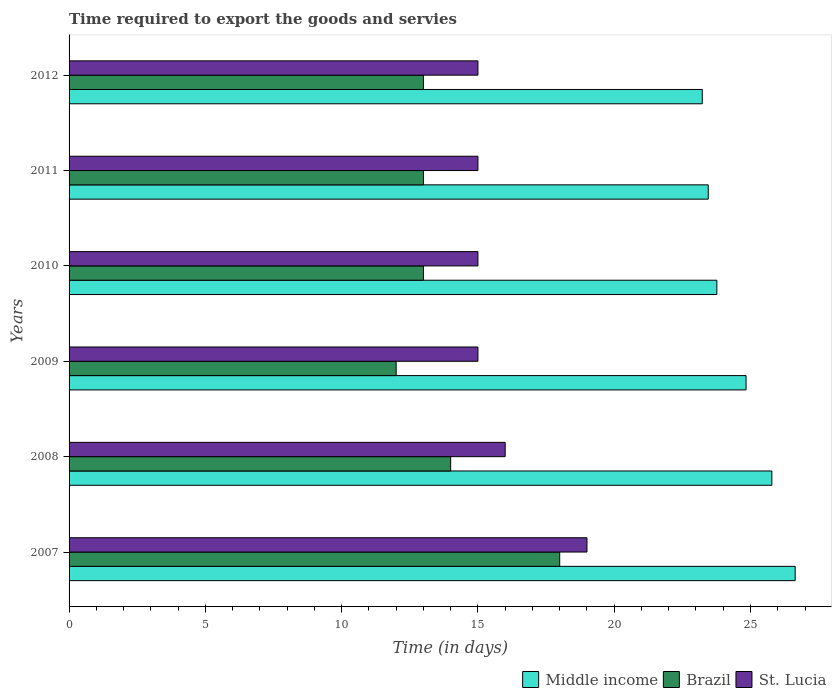How many different coloured bars are there?
Provide a succinct answer. 3. How many groups of bars are there?
Ensure brevity in your answer.  6. Are the number of bars per tick equal to the number of legend labels?
Offer a terse response. Yes. Are the number of bars on each tick of the Y-axis equal?
Provide a succinct answer. Yes. How many bars are there on the 4th tick from the top?
Your answer should be compact. 3. How many bars are there on the 3rd tick from the bottom?
Ensure brevity in your answer.  3. What is the number of days required to export the goods and services in St. Lucia in 2011?
Keep it short and to the point. 15. Across all years, what is the maximum number of days required to export the goods and services in Middle income?
Provide a short and direct response. 26.64. What is the difference between the number of days required to export the goods and services in St. Lucia in 2010 and that in 2011?
Give a very brief answer. 0. What is the difference between the number of days required to export the goods and services in Middle income in 2011 and the number of days required to export the goods and services in Brazil in 2007?
Make the answer very short. 5.45. What is the average number of days required to export the goods and services in Middle income per year?
Make the answer very short. 24.62. In the year 2007, what is the difference between the number of days required to export the goods and services in Brazil and number of days required to export the goods and services in St. Lucia?
Your response must be concise. -1. In how many years, is the number of days required to export the goods and services in St. Lucia greater than 26 days?
Your answer should be compact. 0. What is the ratio of the number of days required to export the goods and services in Brazil in 2008 to that in 2010?
Keep it short and to the point. 1.08. Is the difference between the number of days required to export the goods and services in Brazil in 2007 and 2009 greater than the difference between the number of days required to export the goods and services in St. Lucia in 2007 and 2009?
Provide a short and direct response. Yes. What is the difference between the highest and the lowest number of days required to export the goods and services in Middle income?
Provide a short and direct response. 3.41. Is the sum of the number of days required to export the goods and services in Middle income in 2009 and 2011 greater than the maximum number of days required to export the goods and services in Brazil across all years?
Your answer should be very brief. Yes. What does the 3rd bar from the bottom in 2010 represents?
Keep it short and to the point. St. Lucia. Is it the case that in every year, the sum of the number of days required to export the goods and services in St. Lucia and number of days required to export the goods and services in Middle income is greater than the number of days required to export the goods and services in Brazil?
Provide a short and direct response. Yes. How many bars are there?
Provide a short and direct response. 18. Are all the bars in the graph horizontal?
Provide a short and direct response. Yes. How many years are there in the graph?
Provide a succinct answer. 6. Are the values on the major ticks of X-axis written in scientific E-notation?
Ensure brevity in your answer.  No. How are the legend labels stacked?
Your answer should be very brief. Horizontal. What is the title of the graph?
Your response must be concise. Time required to export the goods and servies. Does "Malaysia" appear as one of the legend labels in the graph?
Your answer should be very brief. No. What is the label or title of the X-axis?
Offer a terse response. Time (in days). What is the Time (in days) of Middle income in 2007?
Give a very brief answer. 26.64. What is the Time (in days) of Middle income in 2008?
Offer a terse response. 25.78. What is the Time (in days) in Brazil in 2008?
Offer a very short reply. 14. What is the Time (in days) of Middle income in 2009?
Give a very brief answer. 24.84. What is the Time (in days) in Brazil in 2009?
Your response must be concise. 12. What is the Time (in days) of Middle income in 2010?
Provide a short and direct response. 23.77. What is the Time (in days) in Brazil in 2010?
Give a very brief answer. 13. What is the Time (in days) in St. Lucia in 2010?
Keep it short and to the point. 15. What is the Time (in days) in Middle income in 2011?
Offer a terse response. 23.45. What is the Time (in days) of Middle income in 2012?
Give a very brief answer. 23.23. Across all years, what is the maximum Time (in days) in Middle income?
Your answer should be very brief. 26.64. Across all years, what is the maximum Time (in days) in Brazil?
Give a very brief answer. 18. Across all years, what is the maximum Time (in days) of St. Lucia?
Your answer should be very brief. 19. Across all years, what is the minimum Time (in days) in Middle income?
Offer a terse response. 23.23. Across all years, what is the minimum Time (in days) of Brazil?
Keep it short and to the point. 12. What is the total Time (in days) in Middle income in the graph?
Ensure brevity in your answer.  147.7. What is the total Time (in days) in St. Lucia in the graph?
Your answer should be compact. 95. What is the difference between the Time (in days) of Middle income in 2007 and that in 2008?
Provide a short and direct response. 0.86. What is the difference between the Time (in days) in Brazil in 2007 and that in 2008?
Give a very brief answer. 4. What is the difference between the Time (in days) in St. Lucia in 2007 and that in 2008?
Provide a short and direct response. 3. What is the difference between the Time (in days) of Middle income in 2007 and that in 2009?
Provide a short and direct response. 1.8. What is the difference between the Time (in days) in Brazil in 2007 and that in 2009?
Your response must be concise. 6. What is the difference between the Time (in days) in Middle income in 2007 and that in 2010?
Your answer should be very brief. 2.87. What is the difference between the Time (in days) of Middle income in 2007 and that in 2011?
Offer a very short reply. 3.19. What is the difference between the Time (in days) in St. Lucia in 2007 and that in 2011?
Provide a short and direct response. 4. What is the difference between the Time (in days) in Middle income in 2007 and that in 2012?
Your answer should be very brief. 3.41. What is the difference between the Time (in days) in St. Lucia in 2007 and that in 2012?
Keep it short and to the point. 4. What is the difference between the Time (in days) in Middle income in 2008 and that in 2009?
Provide a succinct answer. 0.95. What is the difference between the Time (in days) of Brazil in 2008 and that in 2009?
Offer a very short reply. 2. What is the difference between the Time (in days) of Middle income in 2008 and that in 2010?
Your answer should be compact. 2.02. What is the difference between the Time (in days) of Middle income in 2008 and that in 2011?
Ensure brevity in your answer.  2.33. What is the difference between the Time (in days) of Brazil in 2008 and that in 2011?
Keep it short and to the point. 1. What is the difference between the Time (in days) of St. Lucia in 2008 and that in 2011?
Make the answer very short. 1. What is the difference between the Time (in days) in Middle income in 2008 and that in 2012?
Ensure brevity in your answer.  2.55. What is the difference between the Time (in days) of Brazil in 2008 and that in 2012?
Offer a very short reply. 1. What is the difference between the Time (in days) of Middle income in 2009 and that in 2010?
Provide a short and direct response. 1.07. What is the difference between the Time (in days) of St. Lucia in 2009 and that in 2010?
Provide a succinct answer. 0. What is the difference between the Time (in days) of Middle income in 2009 and that in 2011?
Your response must be concise. 1.39. What is the difference between the Time (in days) in Brazil in 2009 and that in 2011?
Keep it short and to the point. -1. What is the difference between the Time (in days) of Middle income in 2009 and that in 2012?
Provide a short and direct response. 1.61. What is the difference between the Time (in days) of Brazil in 2009 and that in 2012?
Give a very brief answer. -1. What is the difference between the Time (in days) of Middle income in 2010 and that in 2011?
Provide a short and direct response. 0.32. What is the difference between the Time (in days) of Brazil in 2010 and that in 2011?
Provide a short and direct response. 0. What is the difference between the Time (in days) in Middle income in 2010 and that in 2012?
Offer a terse response. 0.54. What is the difference between the Time (in days) in Middle income in 2011 and that in 2012?
Keep it short and to the point. 0.22. What is the difference between the Time (in days) of St. Lucia in 2011 and that in 2012?
Ensure brevity in your answer.  0. What is the difference between the Time (in days) of Middle income in 2007 and the Time (in days) of Brazil in 2008?
Give a very brief answer. 12.64. What is the difference between the Time (in days) of Middle income in 2007 and the Time (in days) of St. Lucia in 2008?
Your response must be concise. 10.64. What is the difference between the Time (in days) of Middle income in 2007 and the Time (in days) of Brazil in 2009?
Your response must be concise. 14.64. What is the difference between the Time (in days) in Middle income in 2007 and the Time (in days) in St. Lucia in 2009?
Give a very brief answer. 11.64. What is the difference between the Time (in days) of Brazil in 2007 and the Time (in days) of St. Lucia in 2009?
Provide a short and direct response. 3. What is the difference between the Time (in days) of Middle income in 2007 and the Time (in days) of Brazil in 2010?
Your answer should be compact. 13.64. What is the difference between the Time (in days) in Middle income in 2007 and the Time (in days) in St. Lucia in 2010?
Your answer should be compact. 11.64. What is the difference between the Time (in days) of Brazil in 2007 and the Time (in days) of St. Lucia in 2010?
Give a very brief answer. 3. What is the difference between the Time (in days) in Middle income in 2007 and the Time (in days) in Brazil in 2011?
Provide a short and direct response. 13.64. What is the difference between the Time (in days) in Middle income in 2007 and the Time (in days) in St. Lucia in 2011?
Keep it short and to the point. 11.64. What is the difference between the Time (in days) in Brazil in 2007 and the Time (in days) in St. Lucia in 2011?
Offer a very short reply. 3. What is the difference between the Time (in days) in Middle income in 2007 and the Time (in days) in Brazil in 2012?
Provide a short and direct response. 13.64. What is the difference between the Time (in days) of Middle income in 2007 and the Time (in days) of St. Lucia in 2012?
Ensure brevity in your answer.  11.64. What is the difference between the Time (in days) of Brazil in 2007 and the Time (in days) of St. Lucia in 2012?
Ensure brevity in your answer.  3. What is the difference between the Time (in days) in Middle income in 2008 and the Time (in days) in Brazil in 2009?
Offer a very short reply. 13.78. What is the difference between the Time (in days) in Middle income in 2008 and the Time (in days) in St. Lucia in 2009?
Provide a succinct answer. 10.78. What is the difference between the Time (in days) in Middle income in 2008 and the Time (in days) in Brazil in 2010?
Give a very brief answer. 12.78. What is the difference between the Time (in days) of Middle income in 2008 and the Time (in days) of St. Lucia in 2010?
Give a very brief answer. 10.78. What is the difference between the Time (in days) of Middle income in 2008 and the Time (in days) of Brazil in 2011?
Provide a succinct answer. 12.78. What is the difference between the Time (in days) in Middle income in 2008 and the Time (in days) in St. Lucia in 2011?
Offer a very short reply. 10.78. What is the difference between the Time (in days) of Brazil in 2008 and the Time (in days) of St. Lucia in 2011?
Make the answer very short. -1. What is the difference between the Time (in days) in Middle income in 2008 and the Time (in days) in Brazil in 2012?
Offer a terse response. 12.78. What is the difference between the Time (in days) of Middle income in 2008 and the Time (in days) of St. Lucia in 2012?
Your response must be concise. 10.78. What is the difference between the Time (in days) of Brazil in 2008 and the Time (in days) of St. Lucia in 2012?
Your response must be concise. -1. What is the difference between the Time (in days) of Middle income in 2009 and the Time (in days) of Brazil in 2010?
Ensure brevity in your answer.  11.84. What is the difference between the Time (in days) in Middle income in 2009 and the Time (in days) in St. Lucia in 2010?
Offer a terse response. 9.84. What is the difference between the Time (in days) in Brazil in 2009 and the Time (in days) in St. Lucia in 2010?
Keep it short and to the point. -3. What is the difference between the Time (in days) in Middle income in 2009 and the Time (in days) in Brazil in 2011?
Give a very brief answer. 11.84. What is the difference between the Time (in days) in Middle income in 2009 and the Time (in days) in St. Lucia in 2011?
Your answer should be compact. 9.84. What is the difference between the Time (in days) of Brazil in 2009 and the Time (in days) of St. Lucia in 2011?
Offer a very short reply. -3. What is the difference between the Time (in days) in Middle income in 2009 and the Time (in days) in Brazil in 2012?
Your response must be concise. 11.84. What is the difference between the Time (in days) in Middle income in 2009 and the Time (in days) in St. Lucia in 2012?
Offer a terse response. 9.84. What is the difference between the Time (in days) of Middle income in 2010 and the Time (in days) of Brazil in 2011?
Keep it short and to the point. 10.77. What is the difference between the Time (in days) in Middle income in 2010 and the Time (in days) in St. Lucia in 2011?
Offer a very short reply. 8.77. What is the difference between the Time (in days) of Middle income in 2010 and the Time (in days) of Brazil in 2012?
Offer a terse response. 10.77. What is the difference between the Time (in days) in Middle income in 2010 and the Time (in days) in St. Lucia in 2012?
Give a very brief answer. 8.77. What is the difference between the Time (in days) in Middle income in 2011 and the Time (in days) in Brazil in 2012?
Your answer should be very brief. 10.45. What is the difference between the Time (in days) of Middle income in 2011 and the Time (in days) of St. Lucia in 2012?
Offer a terse response. 8.45. What is the average Time (in days) of Middle income per year?
Your response must be concise. 24.62. What is the average Time (in days) in Brazil per year?
Your answer should be very brief. 13.83. What is the average Time (in days) of St. Lucia per year?
Offer a terse response. 15.83. In the year 2007, what is the difference between the Time (in days) of Middle income and Time (in days) of Brazil?
Your answer should be very brief. 8.64. In the year 2007, what is the difference between the Time (in days) of Middle income and Time (in days) of St. Lucia?
Make the answer very short. 7.64. In the year 2008, what is the difference between the Time (in days) of Middle income and Time (in days) of Brazil?
Offer a terse response. 11.78. In the year 2008, what is the difference between the Time (in days) of Middle income and Time (in days) of St. Lucia?
Offer a very short reply. 9.78. In the year 2008, what is the difference between the Time (in days) of Brazil and Time (in days) of St. Lucia?
Offer a very short reply. -2. In the year 2009, what is the difference between the Time (in days) in Middle income and Time (in days) in Brazil?
Offer a terse response. 12.84. In the year 2009, what is the difference between the Time (in days) of Middle income and Time (in days) of St. Lucia?
Give a very brief answer. 9.84. In the year 2010, what is the difference between the Time (in days) of Middle income and Time (in days) of Brazil?
Your answer should be very brief. 10.77. In the year 2010, what is the difference between the Time (in days) in Middle income and Time (in days) in St. Lucia?
Give a very brief answer. 8.77. In the year 2011, what is the difference between the Time (in days) in Middle income and Time (in days) in Brazil?
Make the answer very short. 10.45. In the year 2011, what is the difference between the Time (in days) of Middle income and Time (in days) of St. Lucia?
Provide a short and direct response. 8.45. In the year 2011, what is the difference between the Time (in days) in Brazil and Time (in days) in St. Lucia?
Your response must be concise. -2. In the year 2012, what is the difference between the Time (in days) in Middle income and Time (in days) in Brazil?
Offer a terse response. 10.23. In the year 2012, what is the difference between the Time (in days) of Middle income and Time (in days) of St. Lucia?
Offer a very short reply. 8.23. What is the ratio of the Time (in days) of Middle income in 2007 to that in 2008?
Provide a succinct answer. 1.03. What is the ratio of the Time (in days) in Brazil in 2007 to that in 2008?
Keep it short and to the point. 1.29. What is the ratio of the Time (in days) of St. Lucia in 2007 to that in 2008?
Offer a terse response. 1.19. What is the ratio of the Time (in days) in Middle income in 2007 to that in 2009?
Offer a very short reply. 1.07. What is the ratio of the Time (in days) of Brazil in 2007 to that in 2009?
Keep it short and to the point. 1.5. What is the ratio of the Time (in days) in St. Lucia in 2007 to that in 2009?
Offer a very short reply. 1.27. What is the ratio of the Time (in days) of Middle income in 2007 to that in 2010?
Provide a short and direct response. 1.12. What is the ratio of the Time (in days) of Brazil in 2007 to that in 2010?
Provide a short and direct response. 1.38. What is the ratio of the Time (in days) of St. Lucia in 2007 to that in 2010?
Make the answer very short. 1.27. What is the ratio of the Time (in days) in Middle income in 2007 to that in 2011?
Provide a short and direct response. 1.14. What is the ratio of the Time (in days) in Brazil in 2007 to that in 2011?
Give a very brief answer. 1.38. What is the ratio of the Time (in days) of St. Lucia in 2007 to that in 2011?
Your response must be concise. 1.27. What is the ratio of the Time (in days) of Middle income in 2007 to that in 2012?
Offer a terse response. 1.15. What is the ratio of the Time (in days) of Brazil in 2007 to that in 2012?
Your answer should be very brief. 1.38. What is the ratio of the Time (in days) of St. Lucia in 2007 to that in 2012?
Provide a succinct answer. 1.27. What is the ratio of the Time (in days) of Middle income in 2008 to that in 2009?
Make the answer very short. 1.04. What is the ratio of the Time (in days) of Brazil in 2008 to that in 2009?
Your answer should be compact. 1.17. What is the ratio of the Time (in days) of St. Lucia in 2008 to that in 2009?
Offer a very short reply. 1.07. What is the ratio of the Time (in days) of Middle income in 2008 to that in 2010?
Ensure brevity in your answer.  1.08. What is the ratio of the Time (in days) of St. Lucia in 2008 to that in 2010?
Offer a very short reply. 1.07. What is the ratio of the Time (in days) in Middle income in 2008 to that in 2011?
Offer a very short reply. 1.1. What is the ratio of the Time (in days) in St. Lucia in 2008 to that in 2011?
Your answer should be very brief. 1.07. What is the ratio of the Time (in days) in Middle income in 2008 to that in 2012?
Offer a very short reply. 1.11. What is the ratio of the Time (in days) of St. Lucia in 2008 to that in 2012?
Provide a succinct answer. 1.07. What is the ratio of the Time (in days) in Middle income in 2009 to that in 2010?
Provide a succinct answer. 1.05. What is the ratio of the Time (in days) of Middle income in 2009 to that in 2011?
Ensure brevity in your answer.  1.06. What is the ratio of the Time (in days) of Brazil in 2009 to that in 2011?
Ensure brevity in your answer.  0.92. What is the ratio of the Time (in days) of Middle income in 2009 to that in 2012?
Offer a terse response. 1.07. What is the ratio of the Time (in days) of Middle income in 2010 to that in 2011?
Ensure brevity in your answer.  1.01. What is the ratio of the Time (in days) in Middle income in 2011 to that in 2012?
Your answer should be compact. 1.01. What is the ratio of the Time (in days) of Brazil in 2011 to that in 2012?
Give a very brief answer. 1. What is the difference between the highest and the second highest Time (in days) of Middle income?
Provide a succinct answer. 0.86. What is the difference between the highest and the second highest Time (in days) in Brazil?
Provide a short and direct response. 4. What is the difference between the highest and the lowest Time (in days) of Middle income?
Keep it short and to the point. 3.41. What is the difference between the highest and the lowest Time (in days) of St. Lucia?
Ensure brevity in your answer.  4. 